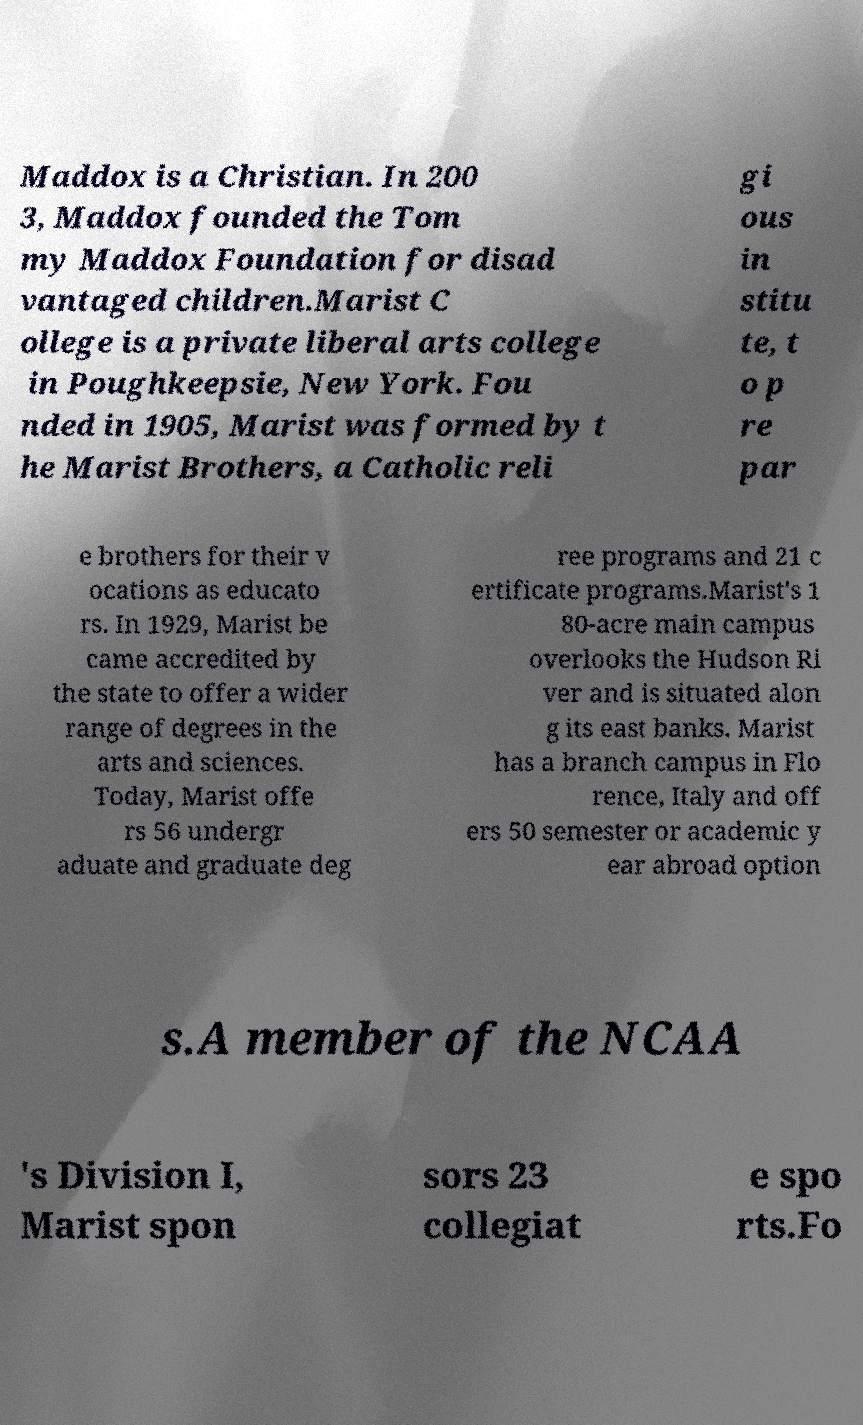Could you assist in decoding the text presented in this image and type it out clearly? Maddox is a Christian. In 200 3, Maddox founded the Tom my Maddox Foundation for disad vantaged children.Marist C ollege is a private liberal arts college in Poughkeepsie, New York. Fou nded in 1905, Marist was formed by t he Marist Brothers, a Catholic reli gi ous in stitu te, t o p re par e brothers for their v ocations as educato rs. In 1929, Marist be came accredited by the state to offer a wider range of degrees in the arts and sciences. Today, Marist offe rs 56 undergr aduate and graduate deg ree programs and 21 c ertificate programs.Marist's 1 80-acre main campus overlooks the Hudson Ri ver and is situated alon g its east banks. Marist has a branch campus in Flo rence, Italy and off ers 50 semester or academic y ear abroad option s.A member of the NCAA 's Division I, Marist spon sors 23 collegiat e spo rts.Fo 